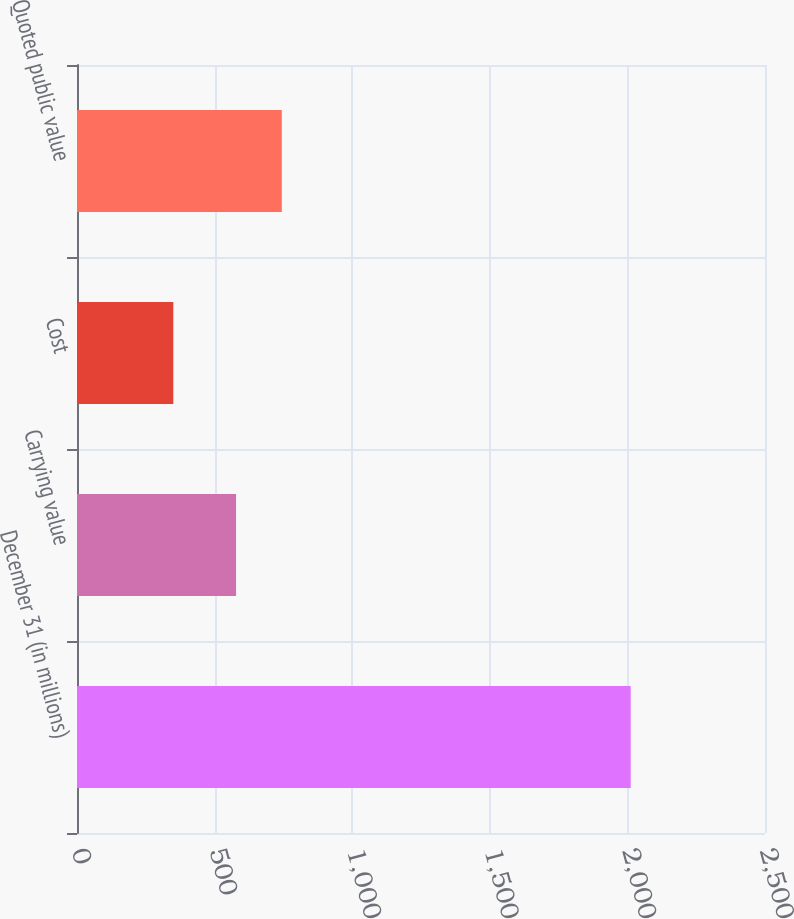Convert chart. <chart><loc_0><loc_0><loc_500><loc_500><bar_chart><fcel>December 31 (in millions)<fcel>Carrying value<fcel>Cost<fcel>Quoted public value<nl><fcel>2012<fcel>578<fcel>350<fcel>744.2<nl></chart> 